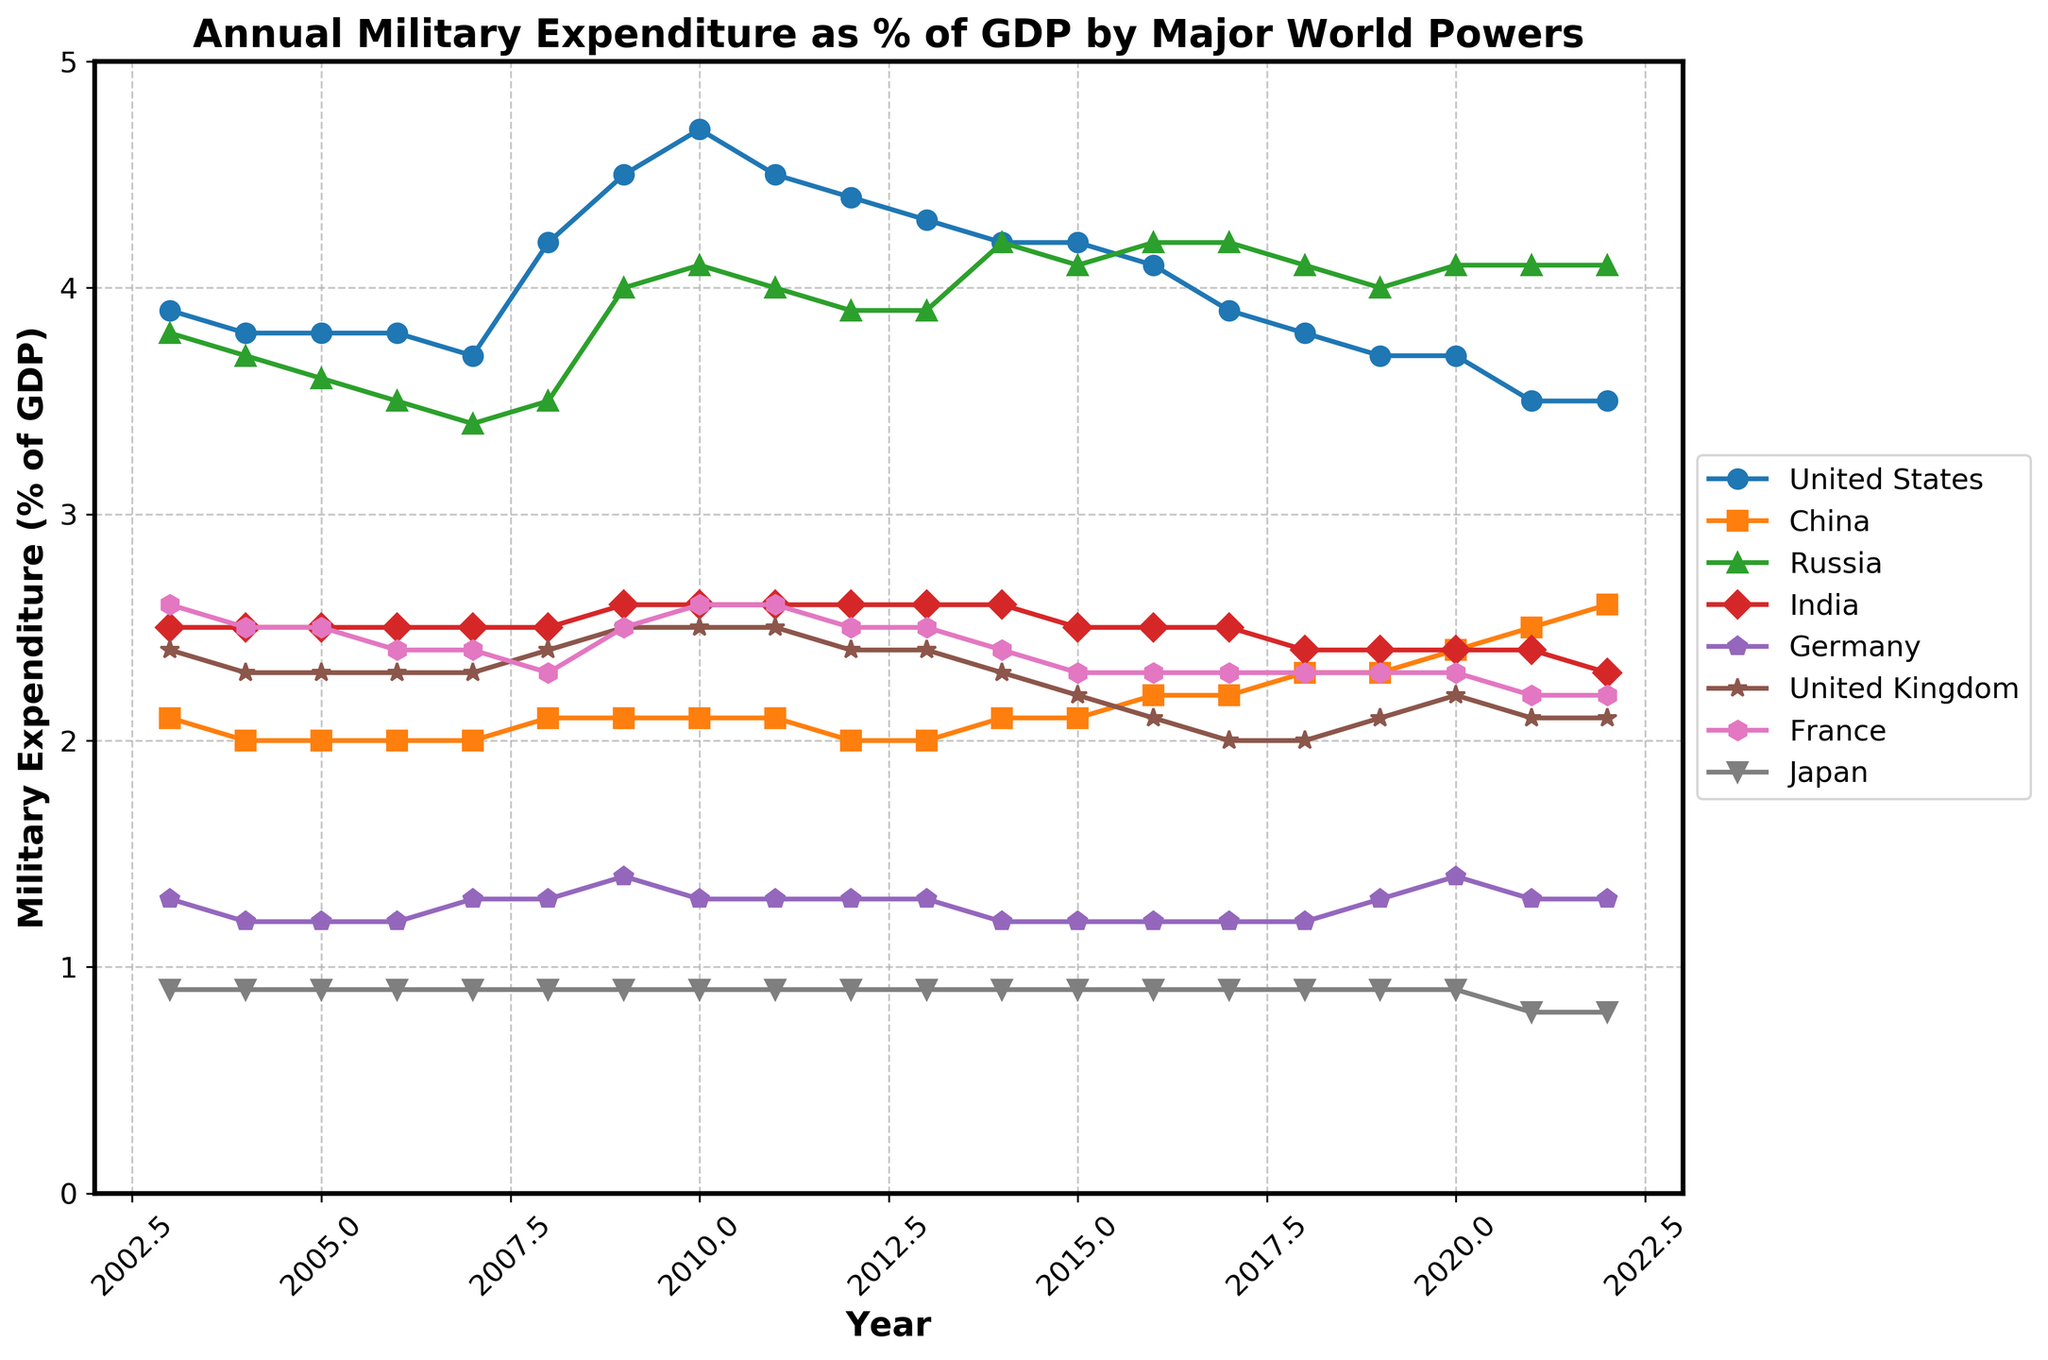What is the title of the plot? The title is usually located at the top of the plot and provides a concise summary of what the plot represents. In this case, it indicates the comparison of military expenditure as a percentage of GDP by major world powers over a period.
Answer: Annual Military Expenditure as % of GDP by Major World Powers What is the highest military expenditure as a percentage of GDP for the United States, and in which year did it occur? Look for the peak point in the time series line for the United States and note the corresponding year on the x-axis.
Answer: 4.7 in 2010 Which country had the lowest military expenditure as a percentage of GDP in 2022? Check the data points for 2022 and identify the country with the smallest value.
Answer: Japan How did China's military expenditure as a percentage of GDP change from 2003 to 2022? Compare the values for China at the beginning (2003) and the end (2022) of the time series plot.
Answer: Increased from 2.1 to 2.6 Between which years did Russia see the highest increase in military expenditure as a percentage of GDP? Identify the period where the difference between consecutive years is the largest for Russia.
Answer: Between 2006 and 2009 Which countries showed a generally decreasing trend in military expenditure as a percentage of GDP over the 20 years? Observe the overall trend line for each country and identify the ones that consistently decrease or have notable declines.
Answer: United States, United Kingdom In which year did India have its peak military expenditure as a percentage of GDP, and what was the value? Locate the peak value on the time series line for India and note the corresponding year.
Answer: 2.6 in 2009 How do the trends in military expenditure as a percentage of GDP for France and Germany compare over the 20 years? Examine both time series lines and describe how they change in relation to each other over time.
Answer: Both remained relatively stable with slight fluctuations What is the average military expenditure as a percentage of GDP for the United Kingdom over the span of 2003 to 2022? Sum the values for the United Kingdom across all years and divide by the total number of years (20).
Answer: (2.4+2.3+2.3+2.3+2.4+2.5+2.5+2.5+2.5+2.4+2.4+2.3+2.2+2.1+2.0+2.0+2.1+2.2+2.1+2.1)/20 = 2.29 